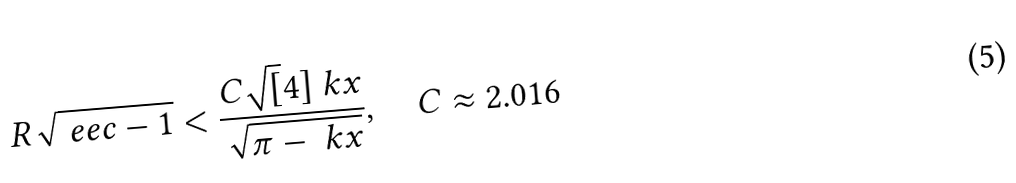Convert formula to latex. <formula><loc_0><loc_0><loc_500><loc_500>R \sqrt { \ e e c - 1 } < \frac { C \sqrt { [ } 4 ] { \ k x } } { \sqrt { \pi - \ k x } } , \quad C \approx 2 . 0 1 6</formula> 